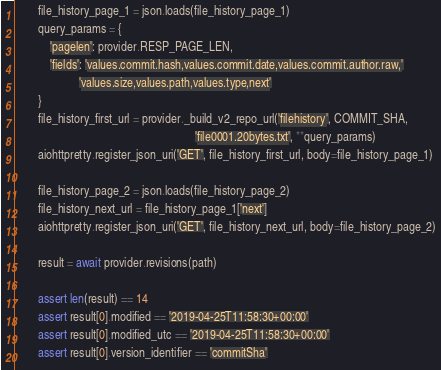Convert code to text. <code><loc_0><loc_0><loc_500><loc_500><_Python_>        file_history_page_1 = json.loads(file_history_page_1)
        query_params = {
            'pagelen': provider.RESP_PAGE_LEN,
            'fields': 'values.commit.hash,values.commit.date,values.commit.author.raw,'
                      'values.size,values.path,values.type,next'
        }
        file_history_first_url = provider._build_v2_repo_url('filehistory', COMMIT_SHA,
                                                             'file0001.20bytes.txt', **query_params)
        aiohttpretty.register_json_uri('GET', file_history_first_url, body=file_history_page_1)

        file_history_page_2 = json.loads(file_history_page_2)
        file_history_next_url = file_history_page_1['next']
        aiohttpretty.register_json_uri('GET', file_history_next_url, body=file_history_page_2)

        result = await provider.revisions(path)

        assert len(result) == 14
        assert result[0].modified == '2019-04-25T11:58:30+00:00'
        assert result[0].modified_utc == '2019-04-25T11:58:30+00:00'
        assert result[0].version_identifier == 'commitSha'</code> 